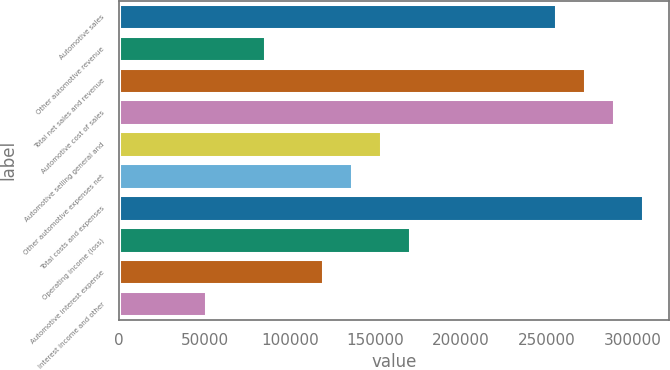Convert chart. <chart><loc_0><loc_0><loc_500><loc_500><bar_chart><fcel>Automotive sales<fcel>Other automotive revenue<fcel>Total net sales and revenue<fcel>Automotive cost of sales<fcel>Automotive selling general and<fcel>Other automotive expenses net<fcel>Total costs and expenses<fcel>Operating income (loss)<fcel>Automotive interest expense<fcel>Interest income and other<nl><fcel>255292<fcel>85126<fcel>272309<fcel>289325<fcel>153192<fcel>136176<fcel>306342<fcel>170209<fcel>119159<fcel>51092.8<nl></chart> 